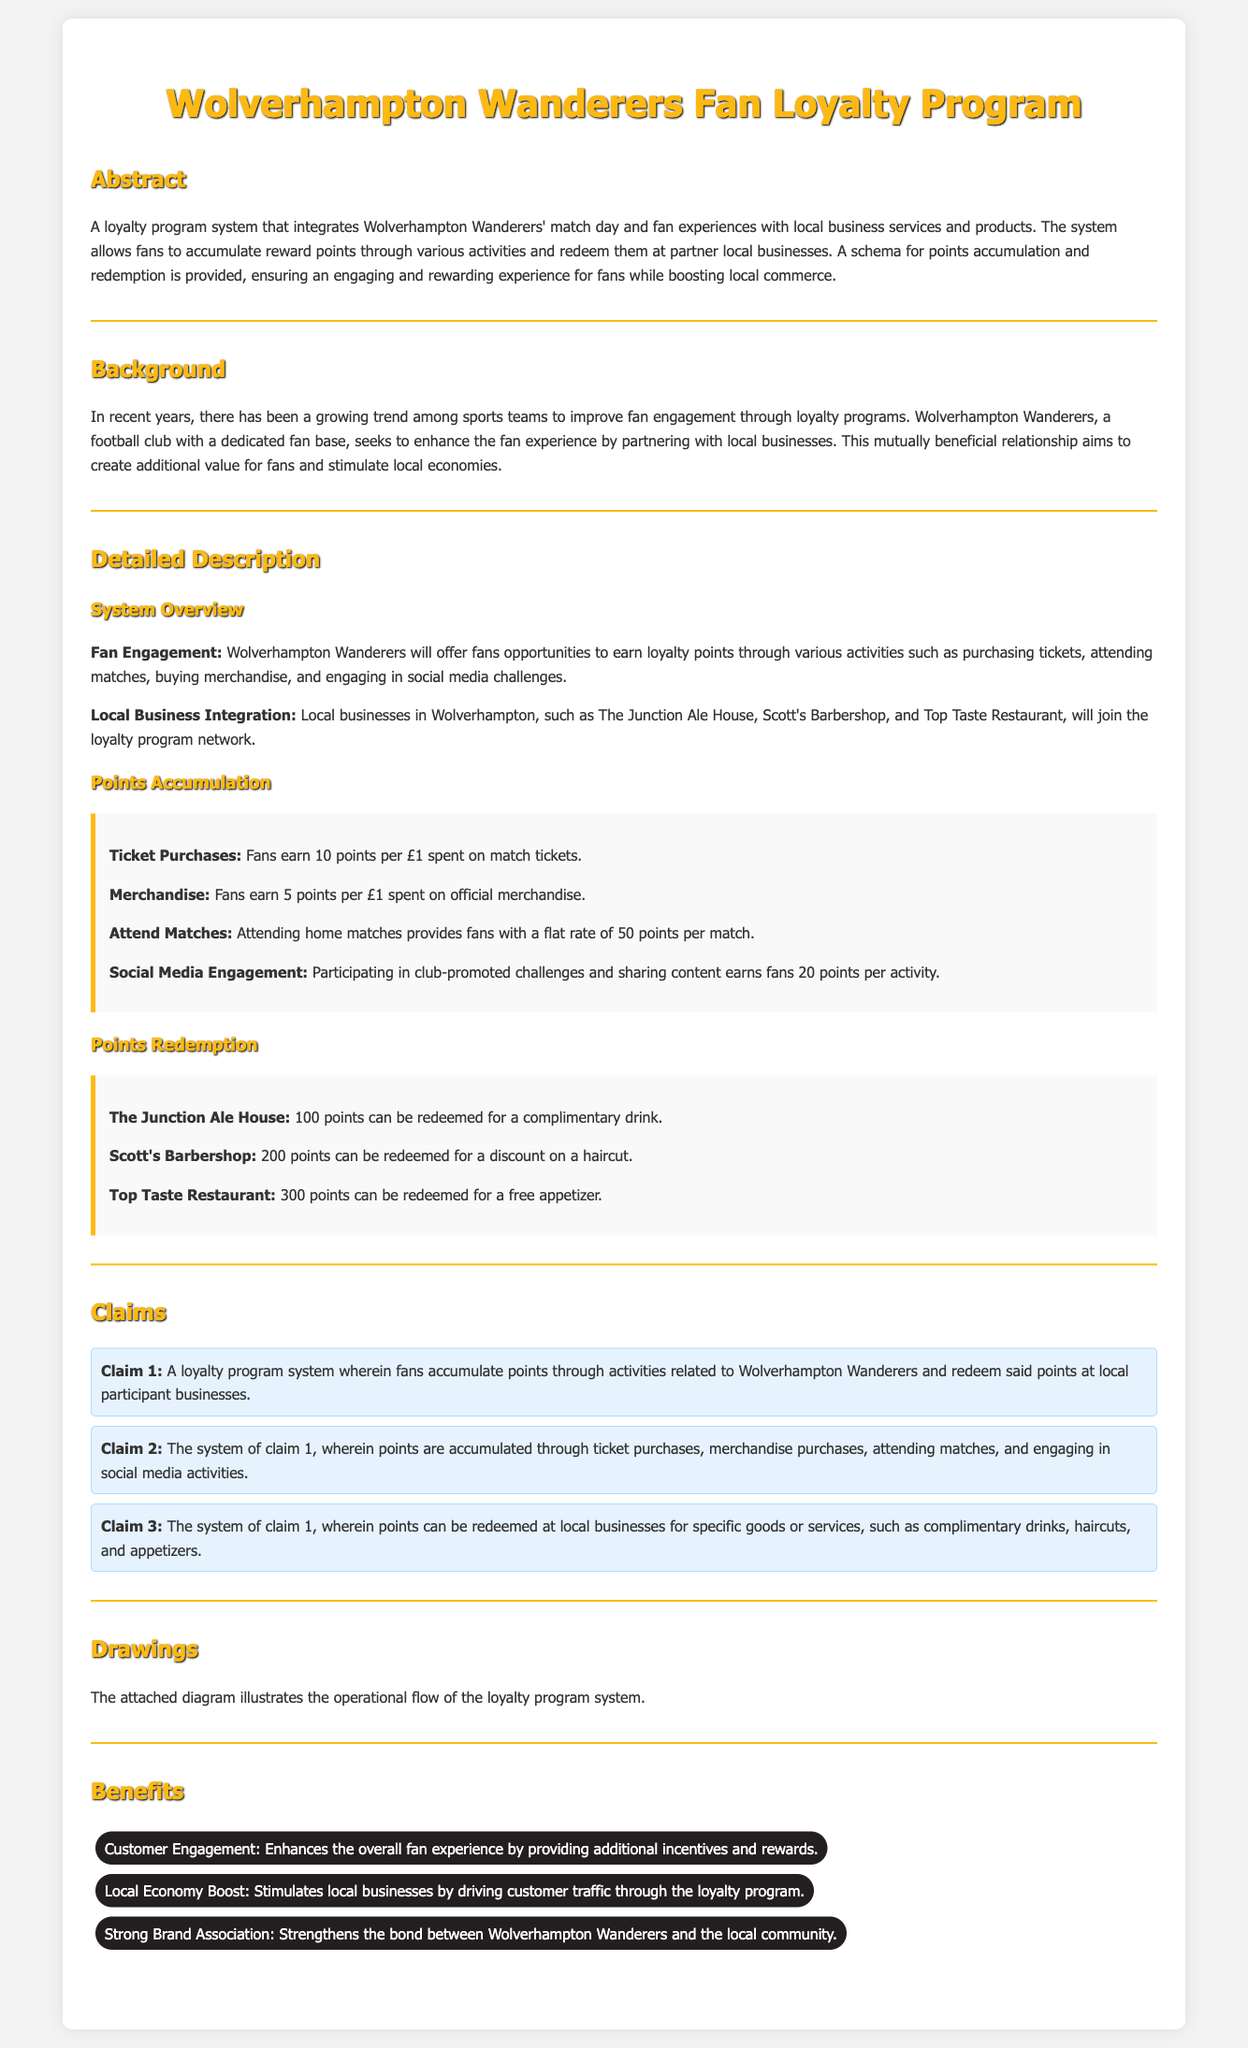What is the title of the document? The title of the document is "Wolverhampton Wanderers Fan Loyalty Program - Patent Application."
Answer: Wolverhampton Wanderers Fan Loyalty Program - Patent Application How many points do fans earn per £1 spent on merchandise? The document states that fans earn 5 points per £1 spent on official merchandise.
Answer: 5 points What can 100 points be redeemed for at The Junction Ale House? According to the document, 100 points can be redeemed for a complimentary drink at The Junction Ale House.
Answer: complimentary drink What is the purpose of the loyalty program? The document mentions the purpose as enhancing the fan experience and stimulating local economies.
Answer: enhancing the fan experience and stimulating local economies What is Claim 3 regarding redeeming points? Claim 3 states that points can be redeemed at local businesses for specific goods or services, such as complimentary drinks, haircuts, and appetizers.
Answer: specific goods or services, such as complimentary drinks, haircuts, and appetizers 